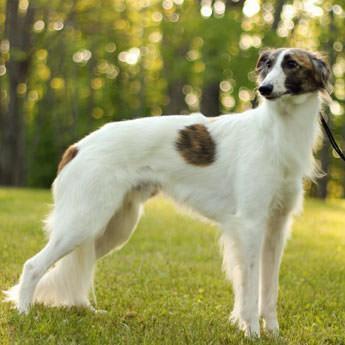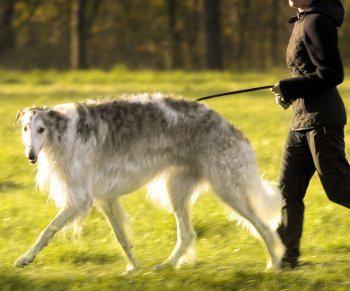The first image is the image on the left, the second image is the image on the right. Assess this claim about the two images: "There are no more than two dogs.". Correct or not? Answer yes or no. Yes. The first image is the image on the left, the second image is the image on the right. Examine the images to the left and right. Is the description "There are more than two dogs." accurate? Answer yes or no. No. 